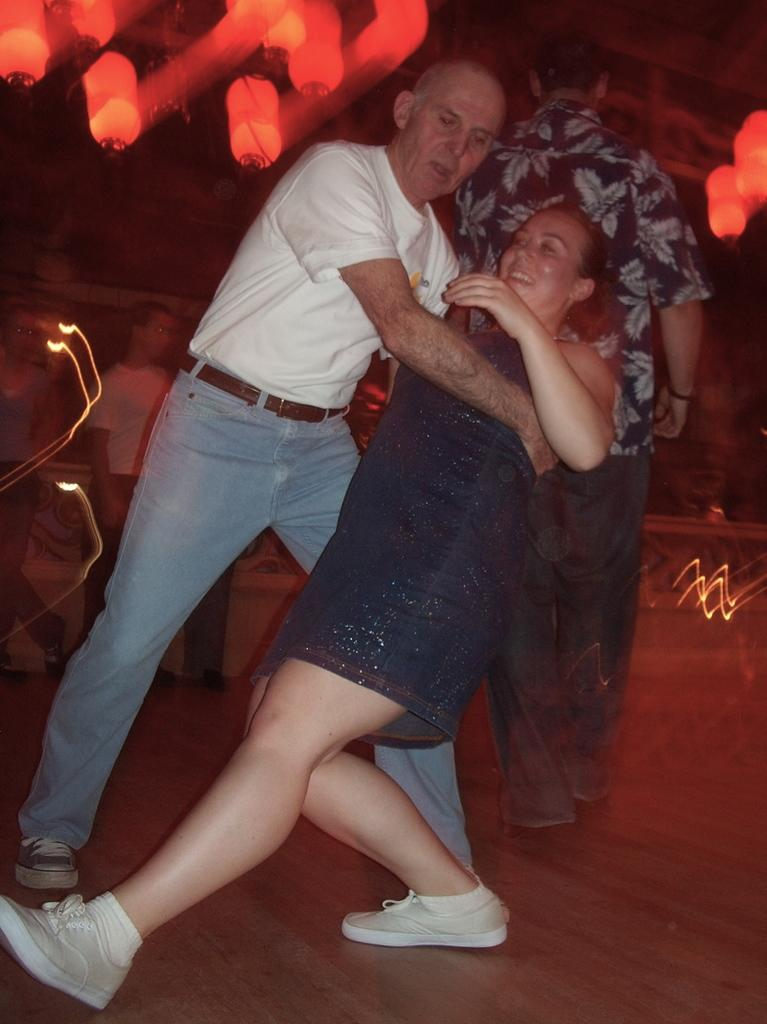Who are the two people in the image? There is a man and a woman in the image. What are the man and woman doing in the image? The man and woman are in a dancing pose. Where are the man and woman located in the image? They are on the floor. Are there any other people in the image? Yes, there are other persons standing behind them. What can be seen in the background or surroundings of the image? Lights are visible in the image. What type of credit is the man holding in the image? There is no credit visible in the image. 